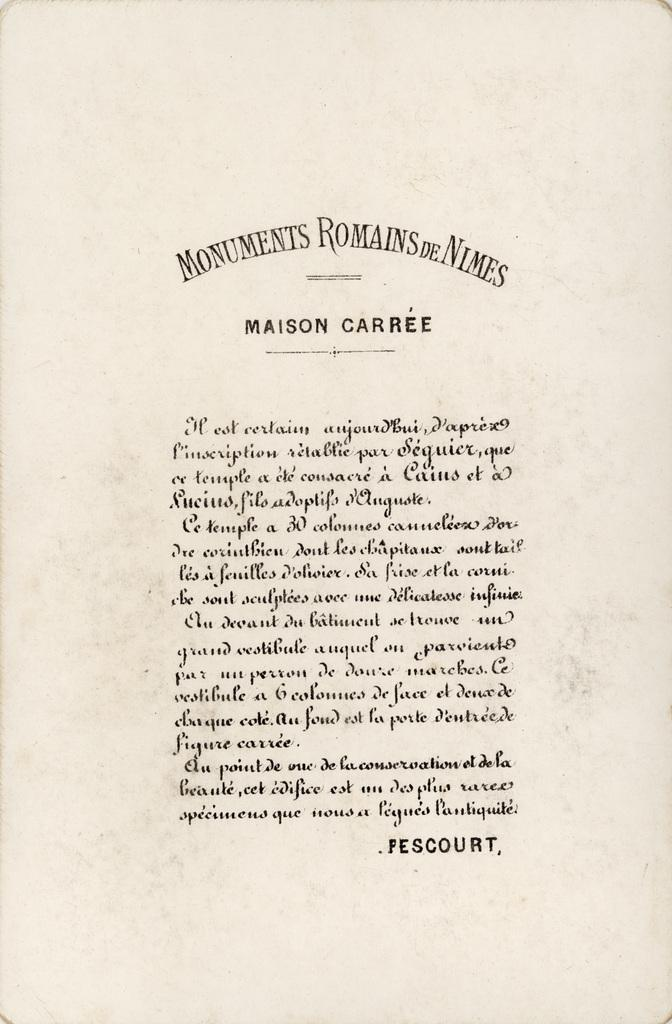<image>
Provide a brief description of the given image. An old piece of paper is written in vintage fonts and is titled "Monuments Romains de Nimes". 